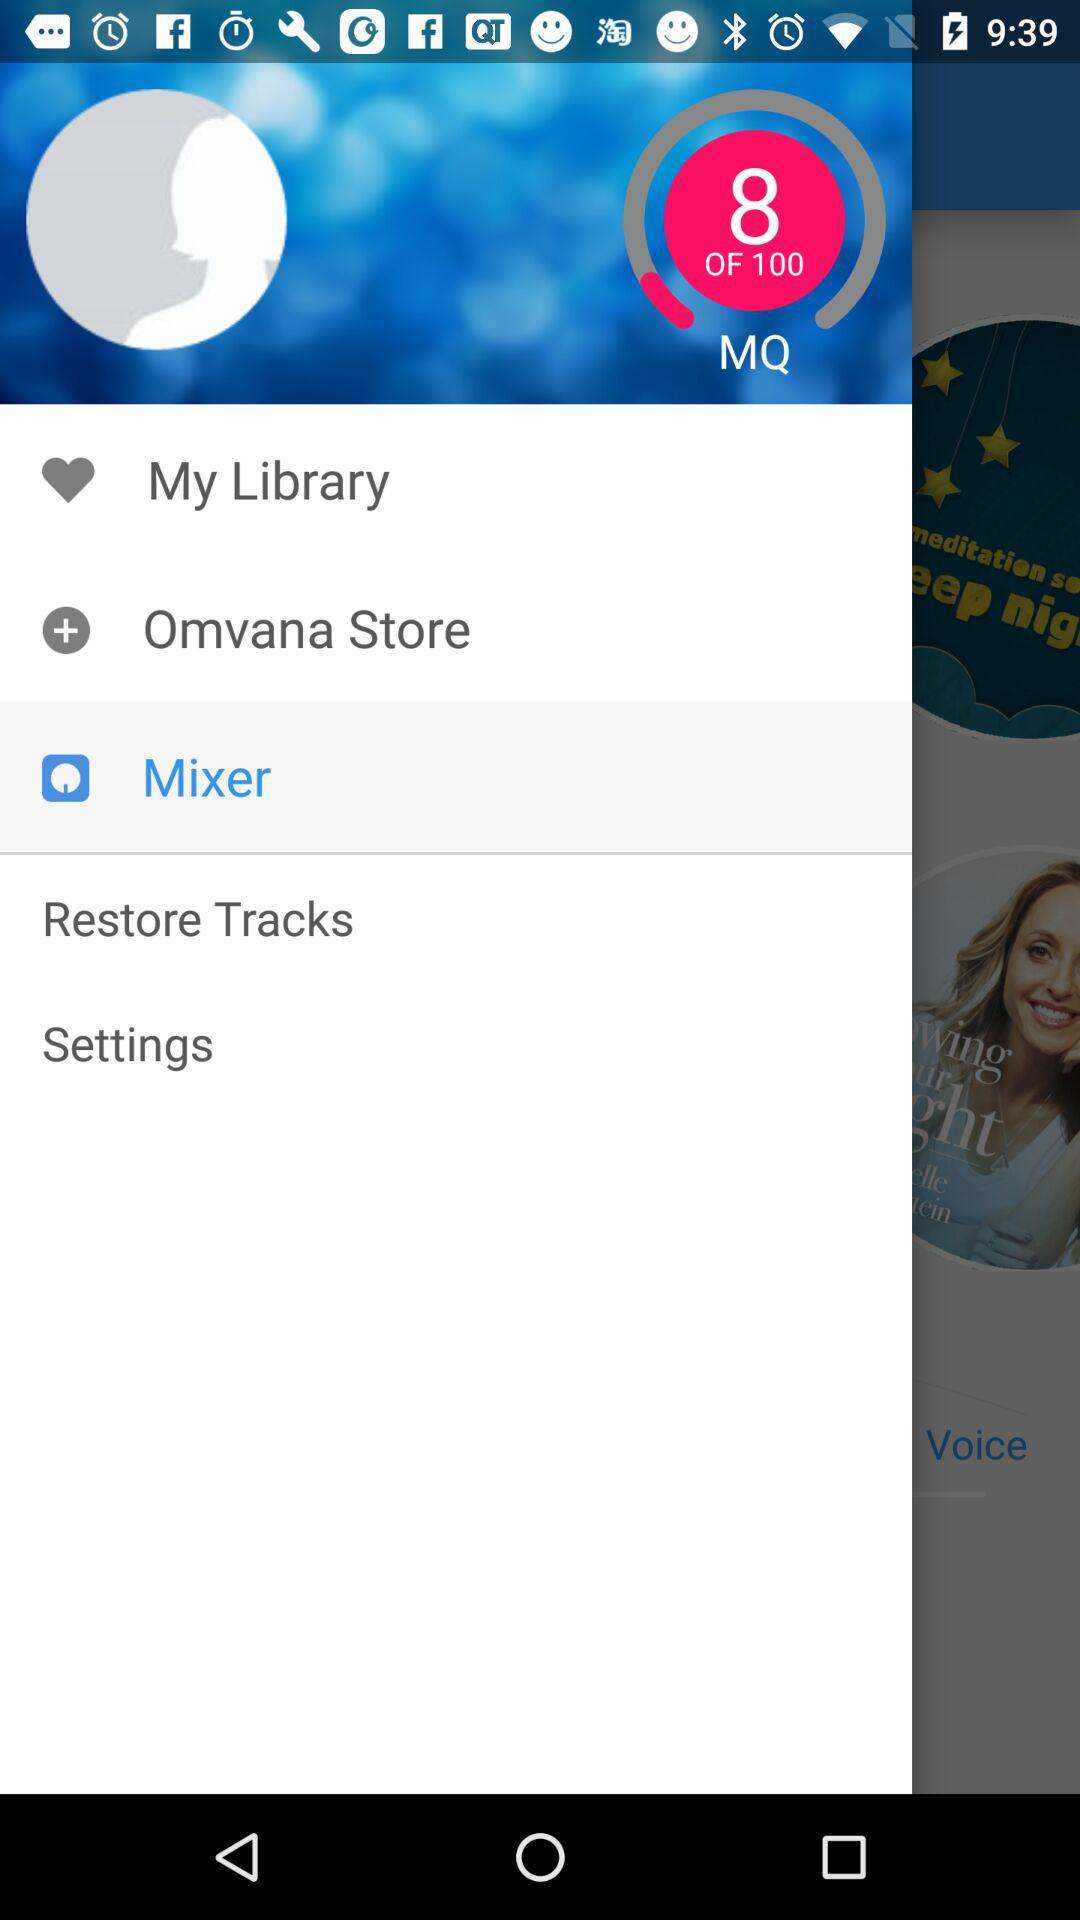Which option is selected? The selected option is "Mixer". 